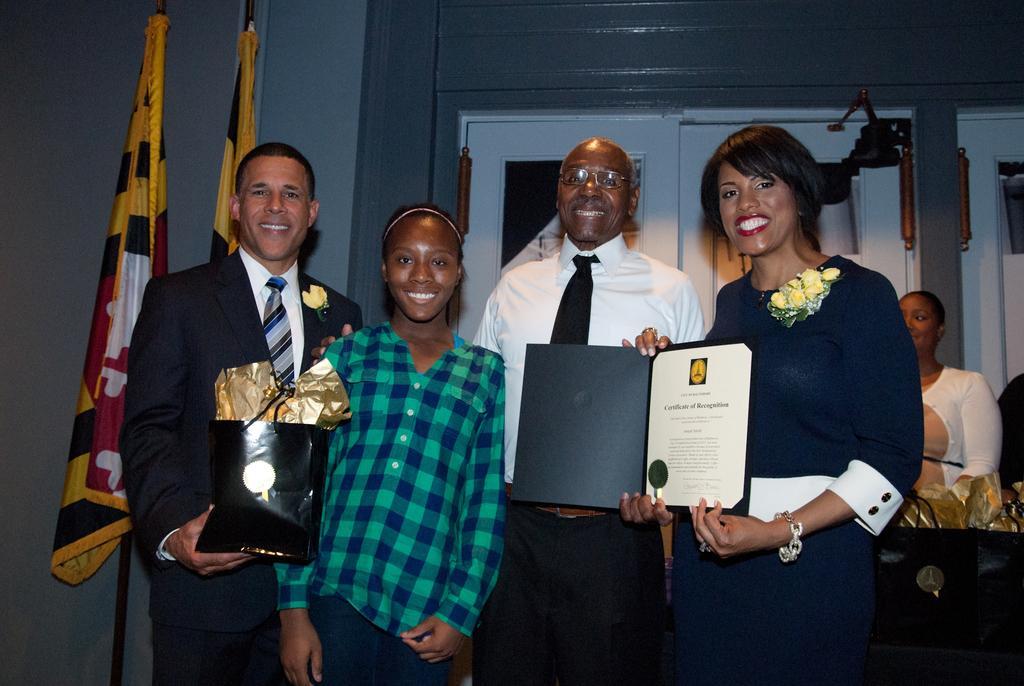Describe this image in one or two sentences. As we can see in the image there is a wall, doors, flags, table and few people standing. The woman standing on the right side is holding a file. 